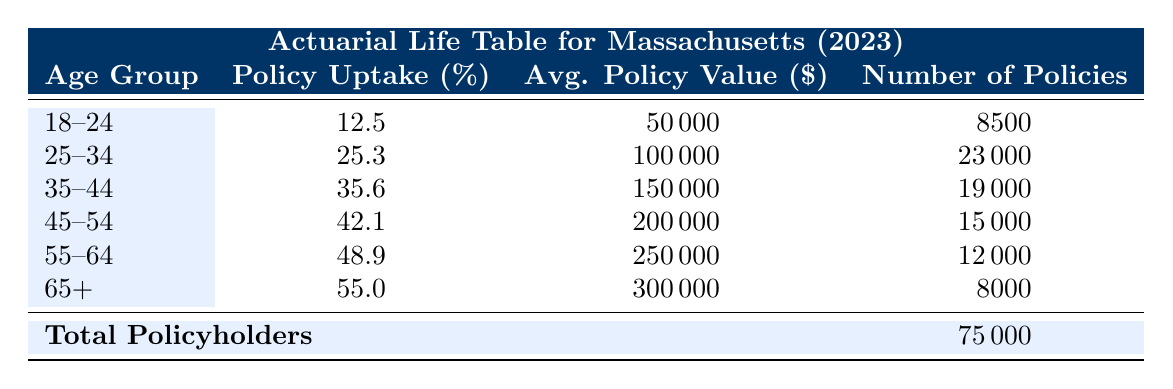What is the policy uptake percentage for the age group 25-34? The table shows that the policy uptake percentage for the 25-34 age group is specifically listed, making it a straightforward retrieval question. Looking directly at the table, the percentage for this age group is 25.3.
Answer: 25.3 Which age group has the highest average policy value? To determine which age group has the highest average policy value, we can compare the values listed under the "Avg. Policy Value" column in the table. The values for the age groups are: 50000, 100000, 150000, 200000, 250000, and 300000. The largest of these is 300000, which corresponds to the 65+ age group.
Answer: 65+ Is the number of policies for the age group 55-64 greater than that for the age group 45-54? By checking the "Number of Policies" for both age groups, we see that 55-64 has 12000 policies, while 45-54 has 15000 policies. Since 12000 is less than 15000, the statement is false.
Answer: No What is the total average policy value across all age groups? To find the total average policy value, we need to calculate the weighted average based on the number of policies sold in each age group. We first multiply the average policy value by the number of policies for each age group. Then we sum these values and divide by the total number of policies (75000). The calculation is as follows: (50000*8500 + 100000*23000 + 150000*19000 + 200000*15000 + 250000*12000 + 300000*8000) / 75000, which gives a total average policy value of 158000.
Answer: 158000 Does the policy uptake percentage increase with age? We can evaluate this by comparing the policy uptake percentages across each age group in the table. The percentages are given as follows: 12.5, 25.3, 35.6, 42.1, 48.9, and 55.0. Since these values consistently increase from the youngest age group to the oldest, we can affirm that the policy uptake percentage does indeed increase with age.
Answer: Yes What is the difference in policy uptake percentage between the age groups 18-24 and 65+? The policy uptake percentages for these two age groups are 12.5 for 18-24 and 55.0 for 65+. To find the difference, we subtract the younger group’s percentage from the older group’s: 55.0 - 12.5 = 42.5.
Answer: 42.5 What is the ratio of the number of policies for the age group 35-44 to the age group 55-64? The number of policies for the 35-44 age group is 19000, and for the 55-64 age group, it is 12000. The ratio can be calculated by dividing the number of policies in 35-44 by that in 55-64: 19000 / 12000, which simplifies to 19/12 or approximately 1.58.
Answer: 1.58 